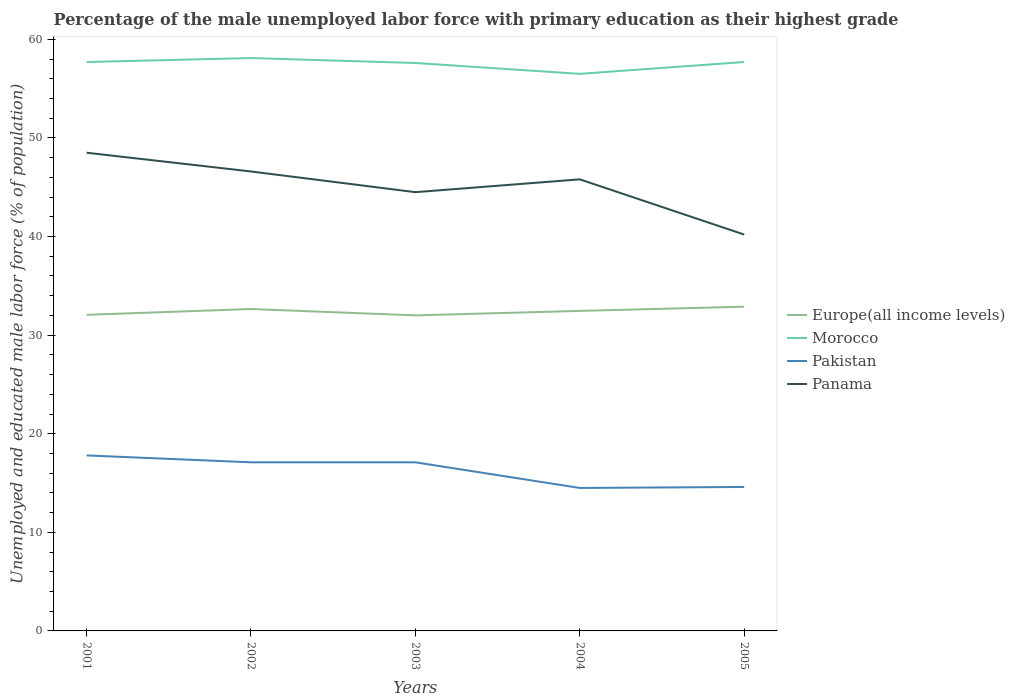How many different coloured lines are there?
Your answer should be very brief. 4. Is the number of lines equal to the number of legend labels?
Give a very brief answer. Yes. Across all years, what is the maximum percentage of the unemployed male labor force with primary education in Europe(all income levels)?
Make the answer very short. 32. In which year was the percentage of the unemployed male labor force with primary education in Pakistan maximum?
Your response must be concise. 2004. What is the total percentage of the unemployed male labor force with primary education in Panama in the graph?
Your answer should be very brief. 6.4. What is the difference between the highest and the second highest percentage of the unemployed male labor force with primary education in Europe(all income levels)?
Your answer should be very brief. 0.88. Is the percentage of the unemployed male labor force with primary education in Europe(all income levels) strictly greater than the percentage of the unemployed male labor force with primary education in Pakistan over the years?
Keep it short and to the point. No. How many lines are there?
Provide a succinct answer. 4. What is the difference between two consecutive major ticks on the Y-axis?
Your answer should be very brief. 10. Does the graph contain any zero values?
Provide a short and direct response. No. What is the title of the graph?
Your response must be concise. Percentage of the male unemployed labor force with primary education as their highest grade. What is the label or title of the Y-axis?
Provide a short and direct response. Unemployed and educated male labor force (% of population). What is the Unemployed and educated male labor force (% of population) of Europe(all income levels) in 2001?
Offer a terse response. 32.06. What is the Unemployed and educated male labor force (% of population) of Morocco in 2001?
Your answer should be very brief. 57.7. What is the Unemployed and educated male labor force (% of population) in Pakistan in 2001?
Offer a terse response. 17.8. What is the Unemployed and educated male labor force (% of population) in Panama in 2001?
Provide a succinct answer. 48.5. What is the Unemployed and educated male labor force (% of population) in Europe(all income levels) in 2002?
Offer a very short reply. 32.65. What is the Unemployed and educated male labor force (% of population) in Morocco in 2002?
Provide a short and direct response. 58.1. What is the Unemployed and educated male labor force (% of population) in Pakistan in 2002?
Give a very brief answer. 17.1. What is the Unemployed and educated male labor force (% of population) in Panama in 2002?
Ensure brevity in your answer.  46.6. What is the Unemployed and educated male labor force (% of population) of Europe(all income levels) in 2003?
Your answer should be very brief. 32. What is the Unemployed and educated male labor force (% of population) of Morocco in 2003?
Ensure brevity in your answer.  57.6. What is the Unemployed and educated male labor force (% of population) of Pakistan in 2003?
Make the answer very short. 17.1. What is the Unemployed and educated male labor force (% of population) in Panama in 2003?
Your response must be concise. 44.5. What is the Unemployed and educated male labor force (% of population) in Europe(all income levels) in 2004?
Give a very brief answer. 32.46. What is the Unemployed and educated male labor force (% of population) in Morocco in 2004?
Make the answer very short. 56.5. What is the Unemployed and educated male labor force (% of population) of Panama in 2004?
Your response must be concise. 45.8. What is the Unemployed and educated male labor force (% of population) in Europe(all income levels) in 2005?
Your response must be concise. 32.88. What is the Unemployed and educated male labor force (% of population) in Morocco in 2005?
Your answer should be very brief. 57.7. What is the Unemployed and educated male labor force (% of population) of Pakistan in 2005?
Make the answer very short. 14.6. What is the Unemployed and educated male labor force (% of population) in Panama in 2005?
Your response must be concise. 40.2. Across all years, what is the maximum Unemployed and educated male labor force (% of population) in Europe(all income levels)?
Your response must be concise. 32.88. Across all years, what is the maximum Unemployed and educated male labor force (% of population) of Morocco?
Offer a very short reply. 58.1. Across all years, what is the maximum Unemployed and educated male labor force (% of population) of Pakistan?
Ensure brevity in your answer.  17.8. Across all years, what is the maximum Unemployed and educated male labor force (% of population) of Panama?
Keep it short and to the point. 48.5. Across all years, what is the minimum Unemployed and educated male labor force (% of population) in Europe(all income levels)?
Your answer should be compact. 32. Across all years, what is the minimum Unemployed and educated male labor force (% of population) in Morocco?
Your answer should be compact. 56.5. Across all years, what is the minimum Unemployed and educated male labor force (% of population) of Panama?
Give a very brief answer. 40.2. What is the total Unemployed and educated male labor force (% of population) of Europe(all income levels) in the graph?
Offer a very short reply. 162.05. What is the total Unemployed and educated male labor force (% of population) of Morocco in the graph?
Provide a short and direct response. 287.6. What is the total Unemployed and educated male labor force (% of population) in Pakistan in the graph?
Your answer should be compact. 81.1. What is the total Unemployed and educated male labor force (% of population) of Panama in the graph?
Provide a short and direct response. 225.6. What is the difference between the Unemployed and educated male labor force (% of population) in Europe(all income levels) in 2001 and that in 2002?
Provide a short and direct response. -0.59. What is the difference between the Unemployed and educated male labor force (% of population) in Morocco in 2001 and that in 2002?
Your answer should be very brief. -0.4. What is the difference between the Unemployed and educated male labor force (% of population) of Pakistan in 2001 and that in 2002?
Your answer should be compact. 0.7. What is the difference between the Unemployed and educated male labor force (% of population) of Panama in 2001 and that in 2002?
Offer a terse response. 1.9. What is the difference between the Unemployed and educated male labor force (% of population) in Europe(all income levels) in 2001 and that in 2003?
Give a very brief answer. 0.06. What is the difference between the Unemployed and educated male labor force (% of population) of Morocco in 2001 and that in 2003?
Your answer should be very brief. 0.1. What is the difference between the Unemployed and educated male labor force (% of population) of Europe(all income levels) in 2001 and that in 2004?
Your response must be concise. -0.4. What is the difference between the Unemployed and educated male labor force (% of population) in Morocco in 2001 and that in 2004?
Provide a succinct answer. 1.2. What is the difference between the Unemployed and educated male labor force (% of population) in Europe(all income levels) in 2001 and that in 2005?
Your answer should be very brief. -0.82. What is the difference between the Unemployed and educated male labor force (% of population) of Morocco in 2001 and that in 2005?
Your answer should be compact. 0. What is the difference between the Unemployed and educated male labor force (% of population) of Pakistan in 2001 and that in 2005?
Make the answer very short. 3.2. What is the difference between the Unemployed and educated male labor force (% of population) of Panama in 2001 and that in 2005?
Your answer should be very brief. 8.3. What is the difference between the Unemployed and educated male labor force (% of population) in Europe(all income levels) in 2002 and that in 2003?
Offer a terse response. 0.65. What is the difference between the Unemployed and educated male labor force (% of population) in Morocco in 2002 and that in 2003?
Make the answer very short. 0.5. What is the difference between the Unemployed and educated male labor force (% of population) in Pakistan in 2002 and that in 2003?
Keep it short and to the point. 0. What is the difference between the Unemployed and educated male labor force (% of population) of Panama in 2002 and that in 2003?
Offer a terse response. 2.1. What is the difference between the Unemployed and educated male labor force (% of population) in Europe(all income levels) in 2002 and that in 2004?
Your answer should be compact. 0.19. What is the difference between the Unemployed and educated male labor force (% of population) in Pakistan in 2002 and that in 2004?
Keep it short and to the point. 2.6. What is the difference between the Unemployed and educated male labor force (% of population) in Panama in 2002 and that in 2004?
Offer a very short reply. 0.8. What is the difference between the Unemployed and educated male labor force (% of population) in Europe(all income levels) in 2002 and that in 2005?
Provide a short and direct response. -0.23. What is the difference between the Unemployed and educated male labor force (% of population) of Morocco in 2002 and that in 2005?
Ensure brevity in your answer.  0.4. What is the difference between the Unemployed and educated male labor force (% of population) of Panama in 2002 and that in 2005?
Your answer should be compact. 6.4. What is the difference between the Unemployed and educated male labor force (% of population) in Europe(all income levels) in 2003 and that in 2004?
Keep it short and to the point. -0.45. What is the difference between the Unemployed and educated male labor force (% of population) in Morocco in 2003 and that in 2004?
Offer a very short reply. 1.1. What is the difference between the Unemployed and educated male labor force (% of population) in Europe(all income levels) in 2003 and that in 2005?
Provide a succinct answer. -0.88. What is the difference between the Unemployed and educated male labor force (% of population) in Pakistan in 2003 and that in 2005?
Your answer should be very brief. 2.5. What is the difference between the Unemployed and educated male labor force (% of population) in Panama in 2003 and that in 2005?
Provide a short and direct response. 4.3. What is the difference between the Unemployed and educated male labor force (% of population) of Europe(all income levels) in 2004 and that in 2005?
Provide a short and direct response. -0.43. What is the difference between the Unemployed and educated male labor force (% of population) in Morocco in 2004 and that in 2005?
Ensure brevity in your answer.  -1.2. What is the difference between the Unemployed and educated male labor force (% of population) in Pakistan in 2004 and that in 2005?
Your answer should be compact. -0.1. What is the difference between the Unemployed and educated male labor force (% of population) of Europe(all income levels) in 2001 and the Unemployed and educated male labor force (% of population) of Morocco in 2002?
Offer a very short reply. -26.04. What is the difference between the Unemployed and educated male labor force (% of population) of Europe(all income levels) in 2001 and the Unemployed and educated male labor force (% of population) of Pakistan in 2002?
Ensure brevity in your answer.  14.96. What is the difference between the Unemployed and educated male labor force (% of population) in Europe(all income levels) in 2001 and the Unemployed and educated male labor force (% of population) in Panama in 2002?
Your response must be concise. -14.54. What is the difference between the Unemployed and educated male labor force (% of population) in Morocco in 2001 and the Unemployed and educated male labor force (% of population) in Pakistan in 2002?
Keep it short and to the point. 40.6. What is the difference between the Unemployed and educated male labor force (% of population) in Pakistan in 2001 and the Unemployed and educated male labor force (% of population) in Panama in 2002?
Provide a succinct answer. -28.8. What is the difference between the Unemployed and educated male labor force (% of population) of Europe(all income levels) in 2001 and the Unemployed and educated male labor force (% of population) of Morocco in 2003?
Offer a very short reply. -25.54. What is the difference between the Unemployed and educated male labor force (% of population) in Europe(all income levels) in 2001 and the Unemployed and educated male labor force (% of population) in Pakistan in 2003?
Offer a terse response. 14.96. What is the difference between the Unemployed and educated male labor force (% of population) in Europe(all income levels) in 2001 and the Unemployed and educated male labor force (% of population) in Panama in 2003?
Your response must be concise. -12.44. What is the difference between the Unemployed and educated male labor force (% of population) in Morocco in 2001 and the Unemployed and educated male labor force (% of population) in Pakistan in 2003?
Provide a succinct answer. 40.6. What is the difference between the Unemployed and educated male labor force (% of population) of Pakistan in 2001 and the Unemployed and educated male labor force (% of population) of Panama in 2003?
Your response must be concise. -26.7. What is the difference between the Unemployed and educated male labor force (% of population) of Europe(all income levels) in 2001 and the Unemployed and educated male labor force (% of population) of Morocco in 2004?
Your response must be concise. -24.44. What is the difference between the Unemployed and educated male labor force (% of population) in Europe(all income levels) in 2001 and the Unemployed and educated male labor force (% of population) in Pakistan in 2004?
Make the answer very short. 17.56. What is the difference between the Unemployed and educated male labor force (% of population) in Europe(all income levels) in 2001 and the Unemployed and educated male labor force (% of population) in Panama in 2004?
Provide a succinct answer. -13.74. What is the difference between the Unemployed and educated male labor force (% of population) in Morocco in 2001 and the Unemployed and educated male labor force (% of population) in Pakistan in 2004?
Give a very brief answer. 43.2. What is the difference between the Unemployed and educated male labor force (% of population) of Morocco in 2001 and the Unemployed and educated male labor force (% of population) of Panama in 2004?
Your answer should be very brief. 11.9. What is the difference between the Unemployed and educated male labor force (% of population) of Pakistan in 2001 and the Unemployed and educated male labor force (% of population) of Panama in 2004?
Your answer should be very brief. -28. What is the difference between the Unemployed and educated male labor force (% of population) in Europe(all income levels) in 2001 and the Unemployed and educated male labor force (% of population) in Morocco in 2005?
Offer a terse response. -25.64. What is the difference between the Unemployed and educated male labor force (% of population) in Europe(all income levels) in 2001 and the Unemployed and educated male labor force (% of population) in Pakistan in 2005?
Keep it short and to the point. 17.46. What is the difference between the Unemployed and educated male labor force (% of population) of Europe(all income levels) in 2001 and the Unemployed and educated male labor force (% of population) of Panama in 2005?
Your answer should be compact. -8.14. What is the difference between the Unemployed and educated male labor force (% of population) of Morocco in 2001 and the Unemployed and educated male labor force (% of population) of Pakistan in 2005?
Make the answer very short. 43.1. What is the difference between the Unemployed and educated male labor force (% of population) in Morocco in 2001 and the Unemployed and educated male labor force (% of population) in Panama in 2005?
Provide a succinct answer. 17.5. What is the difference between the Unemployed and educated male labor force (% of population) of Pakistan in 2001 and the Unemployed and educated male labor force (% of population) of Panama in 2005?
Give a very brief answer. -22.4. What is the difference between the Unemployed and educated male labor force (% of population) of Europe(all income levels) in 2002 and the Unemployed and educated male labor force (% of population) of Morocco in 2003?
Offer a very short reply. -24.95. What is the difference between the Unemployed and educated male labor force (% of population) in Europe(all income levels) in 2002 and the Unemployed and educated male labor force (% of population) in Pakistan in 2003?
Your answer should be very brief. 15.55. What is the difference between the Unemployed and educated male labor force (% of population) in Europe(all income levels) in 2002 and the Unemployed and educated male labor force (% of population) in Panama in 2003?
Your response must be concise. -11.85. What is the difference between the Unemployed and educated male labor force (% of population) of Morocco in 2002 and the Unemployed and educated male labor force (% of population) of Pakistan in 2003?
Ensure brevity in your answer.  41. What is the difference between the Unemployed and educated male labor force (% of population) of Pakistan in 2002 and the Unemployed and educated male labor force (% of population) of Panama in 2003?
Ensure brevity in your answer.  -27.4. What is the difference between the Unemployed and educated male labor force (% of population) in Europe(all income levels) in 2002 and the Unemployed and educated male labor force (% of population) in Morocco in 2004?
Provide a short and direct response. -23.85. What is the difference between the Unemployed and educated male labor force (% of population) in Europe(all income levels) in 2002 and the Unemployed and educated male labor force (% of population) in Pakistan in 2004?
Make the answer very short. 18.15. What is the difference between the Unemployed and educated male labor force (% of population) in Europe(all income levels) in 2002 and the Unemployed and educated male labor force (% of population) in Panama in 2004?
Offer a terse response. -13.15. What is the difference between the Unemployed and educated male labor force (% of population) in Morocco in 2002 and the Unemployed and educated male labor force (% of population) in Pakistan in 2004?
Offer a very short reply. 43.6. What is the difference between the Unemployed and educated male labor force (% of population) in Pakistan in 2002 and the Unemployed and educated male labor force (% of population) in Panama in 2004?
Offer a terse response. -28.7. What is the difference between the Unemployed and educated male labor force (% of population) in Europe(all income levels) in 2002 and the Unemployed and educated male labor force (% of population) in Morocco in 2005?
Your response must be concise. -25.05. What is the difference between the Unemployed and educated male labor force (% of population) in Europe(all income levels) in 2002 and the Unemployed and educated male labor force (% of population) in Pakistan in 2005?
Make the answer very short. 18.05. What is the difference between the Unemployed and educated male labor force (% of population) of Europe(all income levels) in 2002 and the Unemployed and educated male labor force (% of population) of Panama in 2005?
Provide a short and direct response. -7.55. What is the difference between the Unemployed and educated male labor force (% of population) of Morocco in 2002 and the Unemployed and educated male labor force (% of population) of Pakistan in 2005?
Provide a succinct answer. 43.5. What is the difference between the Unemployed and educated male labor force (% of population) in Pakistan in 2002 and the Unemployed and educated male labor force (% of population) in Panama in 2005?
Ensure brevity in your answer.  -23.1. What is the difference between the Unemployed and educated male labor force (% of population) of Europe(all income levels) in 2003 and the Unemployed and educated male labor force (% of population) of Morocco in 2004?
Give a very brief answer. -24.5. What is the difference between the Unemployed and educated male labor force (% of population) of Europe(all income levels) in 2003 and the Unemployed and educated male labor force (% of population) of Pakistan in 2004?
Give a very brief answer. 17.5. What is the difference between the Unemployed and educated male labor force (% of population) in Europe(all income levels) in 2003 and the Unemployed and educated male labor force (% of population) in Panama in 2004?
Your answer should be very brief. -13.8. What is the difference between the Unemployed and educated male labor force (% of population) of Morocco in 2003 and the Unemployed and educated male labor force (% of population) of Pakistan in 2004?
Offer a very short reply. 43.1. What is the difference between the Unemployed and educated male labor force (% of population) of Morocco in 2003 and the Unemployed and educated male labor force (% of population) of Panama in 2004?
Your response must be concise. 11.8. What is the difference between the Unemployed and educated male labor force (% of population) of Pakistan in 2003 and the Unemployed and educated male labor force (% of population) of Panama in 2004?
Offer a terse response. -28.7. What is the difference between the Unemployed and educated male labor force (% of population) in Europe(all income levels) in 2003 and the Unemployed and educated male labor force (% of population) in Morocco in 2005?
Give a very brief answer. -25.7. What is the difference between the Unemployed and educated male labor force (% of population) of Europe(all income levels) in 2003 and the Unemployed and educated male labor force (% of population) of Pakistan in 2005?
Keep it short and to the point. 17.4. What is the difference between the Unemployed and educated male labor force (% of population) in Europe(all income levels) in 2003 and the Unemployed and educated male labor force (% of population) in Panama in 2005?
Provide a short and direct response. -8.2. What is the difference between the Unemployed and educated male labor force (% of population) in Morocco in 2003 and the Unemployed and educated male labor force (% of population) in Pakistan in 2005?
Your response must be concise. 43. What is the difference between the Unemployed and educated male labor force (% of population) of Pakistan in 2003 and the Unemployed and educated male labor force (% of population) of Panama in 2005?
Make the answer very short. -23.1. What is the difference between the Unemployed and educated male labor force (% of population) in Europe(all income levels) in 2004 and the Unemployed and educated male labor force (% of population) in Morocco in 2005?
Give a very brief answer. -25.24. What is the difference between the Unemployed and educated male labor force (% of population) of Europe(all income levels) in 2004 and the Unemployed and educated male labor force (% of population) of Pakistan in 2005?
Your response must be concise. 17.86. What is the difference between the Unemployed and educated male labor force (% of population) of Europe(all income levels) in 2004 and the Unemployed and educated male labor force (% of population) of Panama in 2005?
Your answer should be very brief. -7.74. What is the difference between the Unemployed and educated male labor force (% of population) of Morocco in 2004 and the Unemployed and educated male labor force (% of population) of Pakistan in 2005?
Give a very brief answer. 41.9. What is the difference between the Unemployed and educated male labor force (% of population) in Pakistan in 2004 and the Unemployed and educated male labor force (% of population) in Panama in 2005?
Give a very brief answer. -25.7. What is the average Unemployed and educated male labor force (% of population) of Europe(all income levels) per year?
Make the answer very short. 32.41. What is the average Unemployed and educated male labor force (% of population) in Morocco per year?
Keep it short and to the point. 57.52. What is the average Unemployed and educated male labor force (% of population) in Pakistan per year?
Give a very brief answer. 16.22. What is the average Unemployed and educated male labor force (% of population) in Panama per year?
Provide a succinct answer. 45.12. In the year 2001, what is the difference between the Unemployed and educated male labor force (% of population) of Europe(all income levels) and Unemployed and educated male labor force (% of population) of Morocco?
Your response must be concise. -25.64. In the year 2001, what is the difference between the Unemployed and educated male labor force (% of population) in Europe(all income levels) and Unemployed and educated male labor force (% of population) in Pakistan?
Keep it short and to the point. 14.26. In the year 2001, what is the difference between the Unemployed and educated male labor force (% of population) of Europe(all income levels) and Unemployed and educated male labor force (% of population) of Panama?
Offer a very short reply. -16.44. In the year 2001, what is the difference between the Unemployed and educated male labor force (% of population) of Morocco and Unemployed and educated male labor force (% of population) of Pakistan?
Provide a succinct answer. 39.9. In the year 2001, what is the difference between the Unemployed and educated male labor force (% of population) in Pakistan and Unemployed and educated male labor force (% of population) in Panama?
Make the answer very short. -30.7. In the year 2002, what is the difference between the Unemployed and educated male labor force (% of population) of Europe(all income levels) and Unemployed and educated male labor force (% of population) of Morocco?
Your response must be concise. -25.45. In the year 2002, what is the difference between the Unemployed and educated male labor force (% of population) of Europe(all income levels) and Unemployed and educated male labor force (% of population) of Pakistan?
Offer a terse response. 15.55. In the year 2002, what is the difference between the Unemployed and educated male labor force (% of population) of Europe(all income levels) and Unemployed and educated male labor force (% of population) of Panama?
Provide a short and direct response. -13.95. In the year 2002, what is the difference between the Unemployed and educated male labor force (% of population) in Pakistan and Unemployed and educated male labor force (% of population) in Panama?
Your response must be concise. -29.5. In the year 2003, what is the difference between the Unemployed and educated male labor force (% of population) in Europe(all income levels) and Unemployed and educated male labor force (% of population) in Morocco?
Offer a very short reply. -25.6. In the year 2003, what is the difference between the Unemployed and educated male labor force (% of population) of Europe(all income levels) and Unemployed and educated male labor force (% of population) of Pakistan?
Offer a very short reply. 14.9. In the year 2003, what is the difference between the Unemployed and educated male labor force (% of population) of Europe(all income levels) and Unemployed and educated male labor force (% of population) of Panama?
Provide a short and direct response. -12.5. In the year 2003, what is the difference between the Unemployed and educated male labor force (% of population) in Morocco and Unemployed and educated male labor force (% of population) in Pakistan?
Offer a terse response. 40.5. In the year 2003, what is the difference between the Unemployed and educated male labor force (% of population) in Pakistan and Unemployed and educated male labor force (% of population) in Panama?
Offer a very short reply. -27.4. In the year 2004, what is the difference between the Unemployed and educated male labor force (% of population) of Europe(all income levels) and Unemployed and educated male labor force (% of population) of Morocco?
Provide a short and direct response. -24.04. In the year 2004, what is the difference between the Unemployed and educated male labor force (% of population) of Europe(all income levels) and Unemployed and educated male labor force (% of population) of Pakistan?
Offer a terse response. 17.96. In the year 2004, what is the difference between the Unemployed and educated male labor force (% of population) in Europe(all income levels) and Unemployed and educated male labor force (% of population) in Panama?
Ensure brevity in your answer.  -13.34. In the year 2004, what is the difference between the Unemployed and educated male labor force (% of population) of Morocco and Unemployed and educated male labor force (% of population) of Pakistan?
Offer a very short reply. 42. In the year 2004, what is the difference between the Unemployed and educated male labor force (% of population) in Pakistan and Unemployed and educated male labor force (% of population) in Panama?
Ensure brevity in your answer.  -31.3. In the year 2005, what is the difference between the Unemployed and educated male labor force (% of population) in Europe(all income levels) and Unemployed and educated male labor force (% of population) in Morocco?
Ensure brevity in your answer.  -24.82. In the year 2005, what is the difference between the Unemployed and educated male labor force (% of population) of Europe(all income levels) and Unemployed and educated male labor force (% of population) of Pakistan?
Your response must be concise. 18.28. In the year 2005, what is the difference between the Unemployed and educated male labor force (% of population) in Europe(all income levels) and Unemployed and educated male labor force (% of population) in Panama?
Provide a short and direct response. -7.32. In the year 2005, what is the difference between the Unemployed and educated male labor force (% of population) of Morocco and Unemployed and educated male labor force (% of population) of Pakistan?
Give a very brief answer. 43.1. In the year 2005, what is the difference between the Unemployed and educated male labor force (% of population) in Pakistan and Unemployed and educated male labor force (% of population) in Panama?
Ensure brevity in your answer.  -25.6. What is the ratio of the Unemployed and educated male labor force (% of population) of Europe(all income levels) in 2001 to that in 2002?
Give a very brief answer. 0.98. What is the ratio of the Unemployed and educated male labor force (% of population) in Pakistan in 2001 to that in 2002?
Offer a terse response. 1.04. What is the ratio of the Unemployed and educated male labor force (% of population) of Panama in 2001 to that in 2002?
Keep it short and to the point. 1.04. What is the ratio of the Unemployed and educated male labor force (% of population) in Pakistan in 2001 to that in 2003?
Give a very brief answer. 1.04. What is the ratio of the Unemployed and educated male labor force (% of population) of Panama in 2001 to that in 2003?
Offer a very short reply. 1.09. What is the ratio of the Unemployed and educated male labor force (% of population) of Morocco in 2001 to that in 2004?
Your answer should be compact. 1.02. What is the ratio of the Unemployed and educated male labor force (% of population) of Pakistan in 2001 to that in 2004?
Offer a very short reply. 1.23. What is the ratio of the Unemployed and educated male labor force (% of population) in Panama in 2001 to that in 2004?
Your answer should be compact. 1.06. What is the ratio of the Unemployed and educated male labor force (% of population) in Europe(all income levels) in 2001 to that in 2005?
Ensure brevity in your answer.  0.97. What is the ratio of the Unemployed and educated male labor force (% of population) of Pakistan in 2001 to that in 2005?
Make the answer very short. 1.22. What is the ratio of the Unemployed and educated male labor force (% of population) in Panama in 2001 to that in 2005?
Make the answer very short. 1.21. What is the ratio of the Unemployed and educated male labor force (% of population) in Europe(all income levels) in 2002 to that in 2003?
Provide a short and direct response. 1.02. What is the ratio of the Unemployed and educated male labor force (% of population) of Morocco in 2002 to that in 2003?
Provide a short and direct response. 1.01. What is the ratio of the Unemployed and educated male labor force (% of population) in Pakistan in 2002 to that in 2003?
Offer a terse response. 1. What is the ratio of the Unemployed and educated male labor force (% of population) in Panama in 2002 to that in 2003?
Your answer should be compact. 1.05. What is the ratio of the Unemployed and educated male labor force (% of population) of Europe(all income levels) in 2002 to that in 2004?
Your answer should be compact. 1.01. What is the ratio of the Unemployed and educated male labor force (% of population) in Morocco in 2002 to that in 2004?
Offer a terse response. 1.03. What is the ratio of the Unemployed and educated male labor force (% of population) of Pakistan in 2002 to that in 2004?
Make the answer very short. 1.18. What is the ratio of the Unemployed and educated male labor force (% of population) in Panama in 2002 to that in 2004?
Offer a very short reply. 1.02. What is the ratio of the Unemployed and educated male labor force (% of population) of Pakistan in 2002 to that in 2005?
Make the answer very short. 1.17. What is the ratio of the Unemployed and educated male labor force (% of population) in Panama in 2002 to that in 2005?
Provide a short and direct response. 1.16. What is the ratio of the Unemployed and educated male labor force (% of population) of Europe(all income levels) in 2003 to that in 2004?
Provide a succinct answer. 0.99. What is the ratio of the Unemployed and educated male labor force (% of population) in Morocco in 2003 to that in 2004?
Your answer should be compact. 1.02. What is the ratio of the Unemployed and educated male labor force (% of population) in Pakistan in 2003 to that in 2004?
Make the answer very short. 1.18. What is the ratio of the Unemployed and educated male labor force (% of population) of Panama in 2003 to that in 2004?
Ensure brevity in your answer.  0.97. What is the ratio of the Unemployed and educated male labor force (% of population) in Europe(all income levels) in 2003 to that in 2005?
Provide a succinct answer. 0.97. What is the ratio of the Unemployed and educated male labor force (% of population) of Morocco in 2003 to that in 2005?
Keep it short and to the point. 1. What is the ratio of the Unemployed and educated male labor force (% of population) of Pakistan in 2003 to that in 2005?
Provide a short and direct response. 1.17. What is the ratio of the Unemployed and educated male labor force (% of population) in Panama in 2003 to that in 2005?
Your answer should be very brief. 1.11. What is the ratio of the Unemployed and educated male labor force (% of population) of Europe(all income levels) in 2004 to that in 2005?
Keep it short and to the point. 0.99. What is the ratio of the Unemployed and educated male labor force (% of population) in Morocco in 2004 to that in 2005?
Offer a terse response. 0.98. What is the ratio of the Unemployed and educated male labor force (% of population) of Pakistan in 2004 to that in 2005?
Your response must be concise. 0.99. What is the ratio of the Unemployed and educated male labor force (% of population) of Panama in 2004 to that in 2005?
Give a very brief answer. 1.14. What is the difference between the highest and the second highest Unemployed and educated male labor force (% of population) of Europe(all income levels)?
Provide a succinct answer. 0.23. What is the difference between the highest and the second highest Unemployed and educated male labor force (% of population) of Morocco?
Your answer should be very brief. 0.4. What is the difference between the highest and the lowest Unemployed and educated male labor force (% of population) in Europe(all income levels)?
Offer a very short reply. 0.88. What is the difference between the highest and the lowest Unemployed and educated male labor force (% of population) of Pakistan?
Keep it short and to the point. 3.3. 